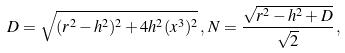Convert formula to latex. <formula><loc_0><loc_0><loc_500><loc_500>D = \sqrt { ( r ^ { 2 } - h ^ { 2 } ) ^ { 2 } + 4 h ^ { 2 } ( x ^ { 3 } ) ^ { 2 } } \, , \, N = \frac { \sqrt { r ^ { 2 } - h ^ { 2 } + D } } { \sqrt { 2 } } \, ,</formula> 